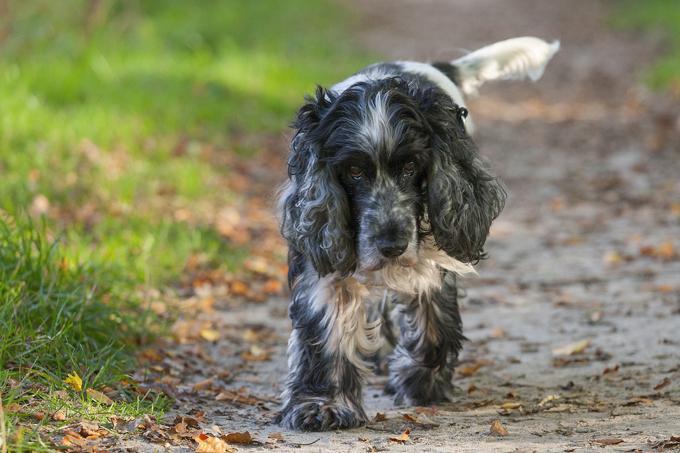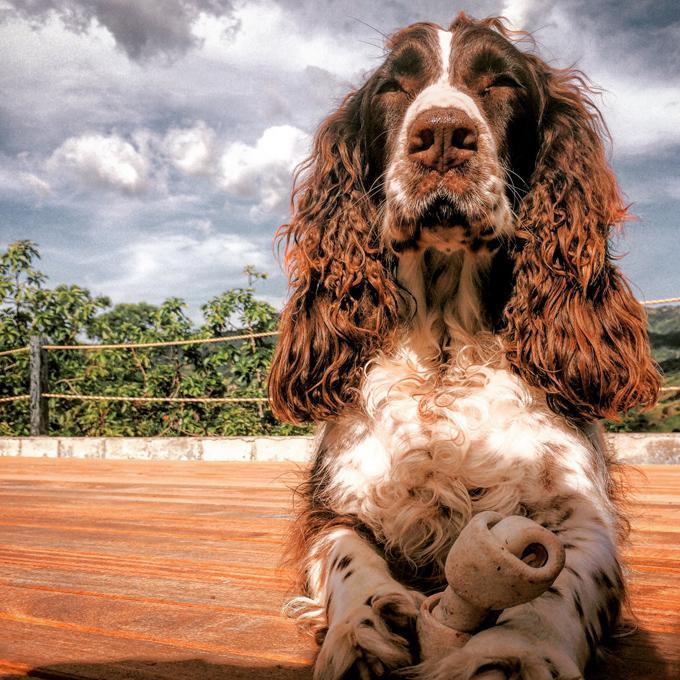The first image is the image on the left, the second image is the image on the right. Evaluate the accuracy of this statement regarding the images: "There are at least four dogs.". Is it true? Answer yes or no. No. 